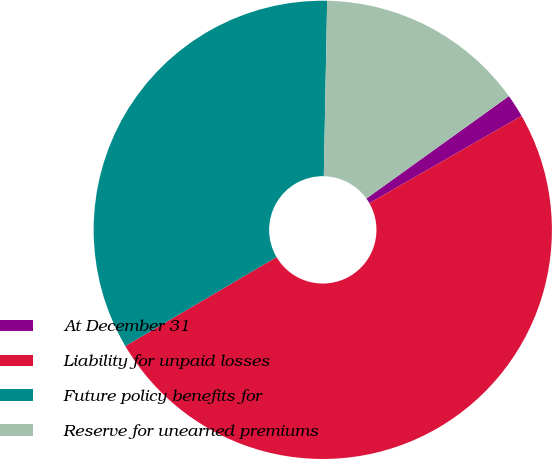Convert chart to OTSL. <chart><loc_0><loc_0><loc_500><loc_500><pie_chart><fcel>At December 31<fcel>Liability for unpaid losses<fcel>Future policy benefits for<fcel>Reserve for unearned premiums<nl><fcel>1.63%<fcel>49.82%<fcel>33.77%<fcel>14.78%<nl></chart> 